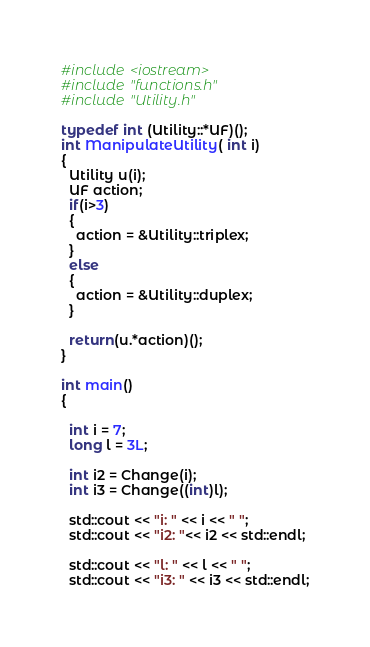<code> <loc_0><loc_0><loc_500><loc_500><_C++_>#include <iostream>
#include "functions.h"
#include "Utility.h"

typedef int (Utility::*UF)();
int ManipulateUtility( int i)
{
  Utility u(i);
  UF action;
  if(i>3)
  {
    action = &Utility::triplex;
  }
  else
  {
    action = &Utility::duplex;
  }

  return(u.*action)();
}

int main()
{

  int i = 7;
  long l = 3L;

  int i2 = Change(i);
  int i3 = Change((int)l);

  std::cout << "i: " << i << " ";
  std::cout << "i2: "<< i2 << std::endl;

  std::cout << "l: " << l << " ";
  std::cout << "i3: " << i3 << std::endl;
</code> 